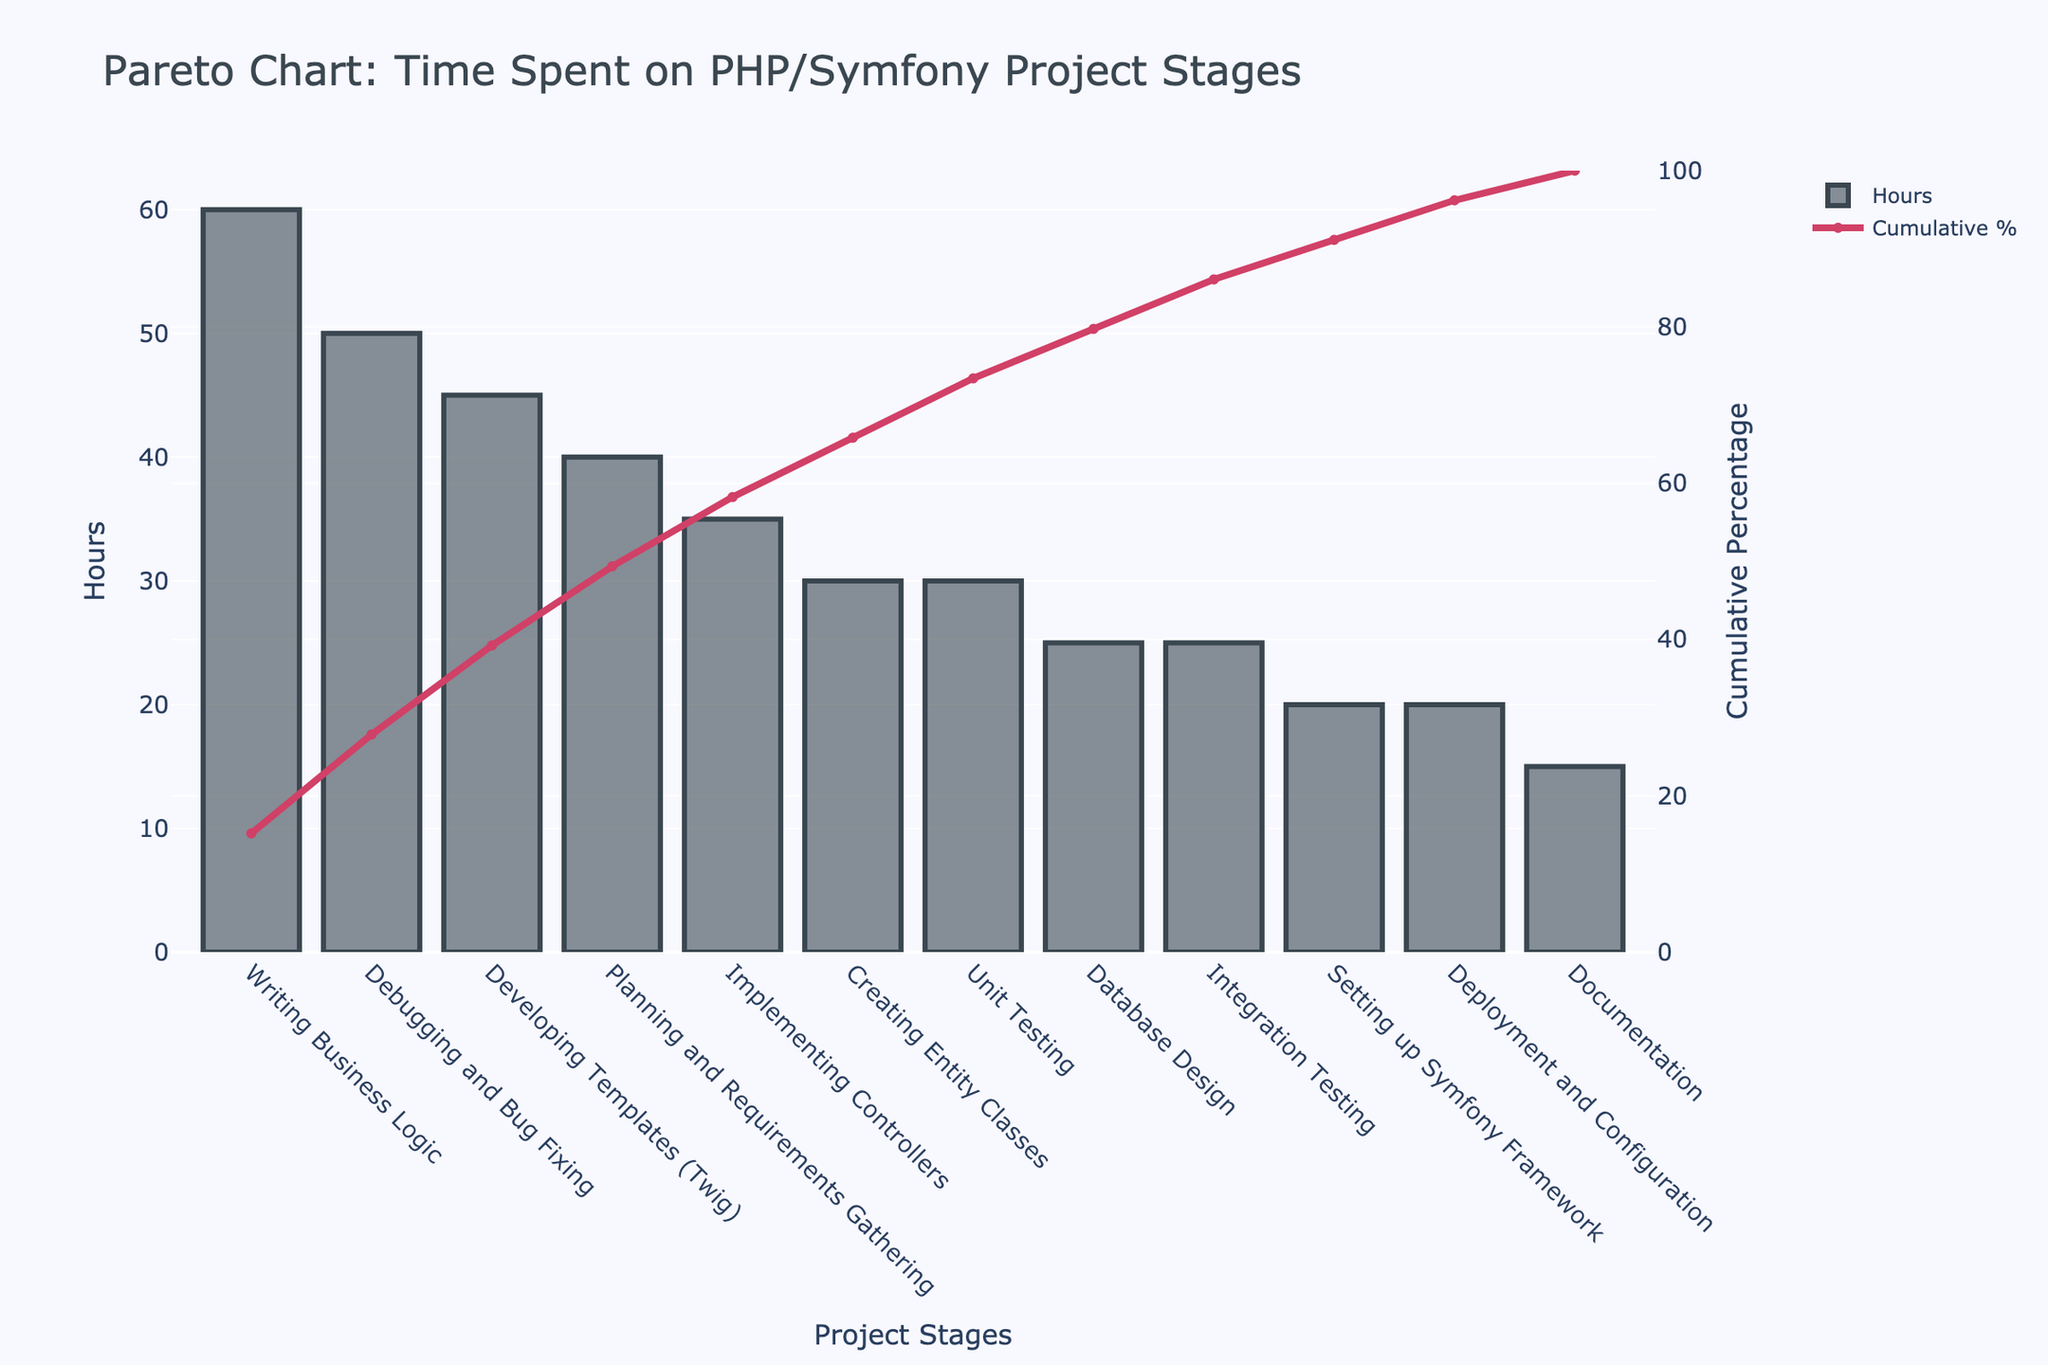What is the title of the chart? The title of the chart is typically displayed at the top of the figure and describes the subject or content of the visual representation. In this case, it appears at the top center and reads "Pareto Chart: Time Spent on PHP/Symfony Project Stages"
Answer: Pareto Chart: Time Spent on PHP/Symfony Project Stages What does the y-axis on the left represent? The y-axis on the left side of the chart shows the numeric values associated with each bar, which in this case represents the hours spent on each stage of the project.
Answer: Hours Which project stage has the highest number of hours? The bar with the highest height corresponds to the project stage with the maximum hours. Here, "Writing Business Logic" has the highest bar.
Answer: Writing Business Logic What is the cumulative percentage for the stage "Developing Templates (Twig)"? Find the point on the cumulative percentage curve that corresponds to the "Developing Templates (Twig)" on the x-axis. The cumulative percentage value is given directly under this point. It is approximately 50%.
Answer: 50% How many hours were spent on Unit Testing and Integration Testing combined? Add the hours for "Unit Testing" (30 hours) and "Integration Testing" (25 hours) to get the total hours spent on both combined.
Answer: 55 hours What stage comes immediately after "Writing Business Logic" in the cumulative percentage curve? The stage that follows "Writing Business Logic" on the x-axis in a Pareto chart is "Debugging and Bug Fixing," when tracking the order of bars and points on the cumulative curve.
Answer: Debugging and Bug Fixing Which stage contributed the least to the total hours spent? The stage with the shortest bar represents the stage with the least hours spent, which in this case is "Documentation."
Answer: Documentation What is the cumulative percentage up to and including the stage "Creating Entity Classes"? Find the cumulative percentage value at the "Creating Entity Classes" point on the cumulative percentage curve. It is just over 50%.
Answer: Just over 50% How many stages taken together make up at least 80% of the total hours? Identify the point on the cumulative percentage curve that reaches or exceeds 80%. Count the number of stages up to and including this point.
Answer: 8 stages Between which two stages is there the largest difference in hours? Look for the two adjacent bars with the largest difference in height. The stages "Writing Business Logic" and "Debugging and Bug Fixing" represent the largest difference.
Answer: Writing Business Logic and Debugging and Bug Fixing 